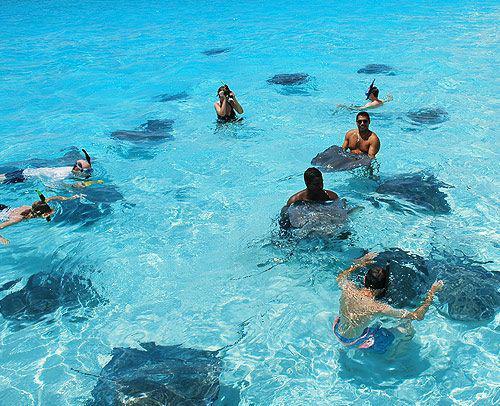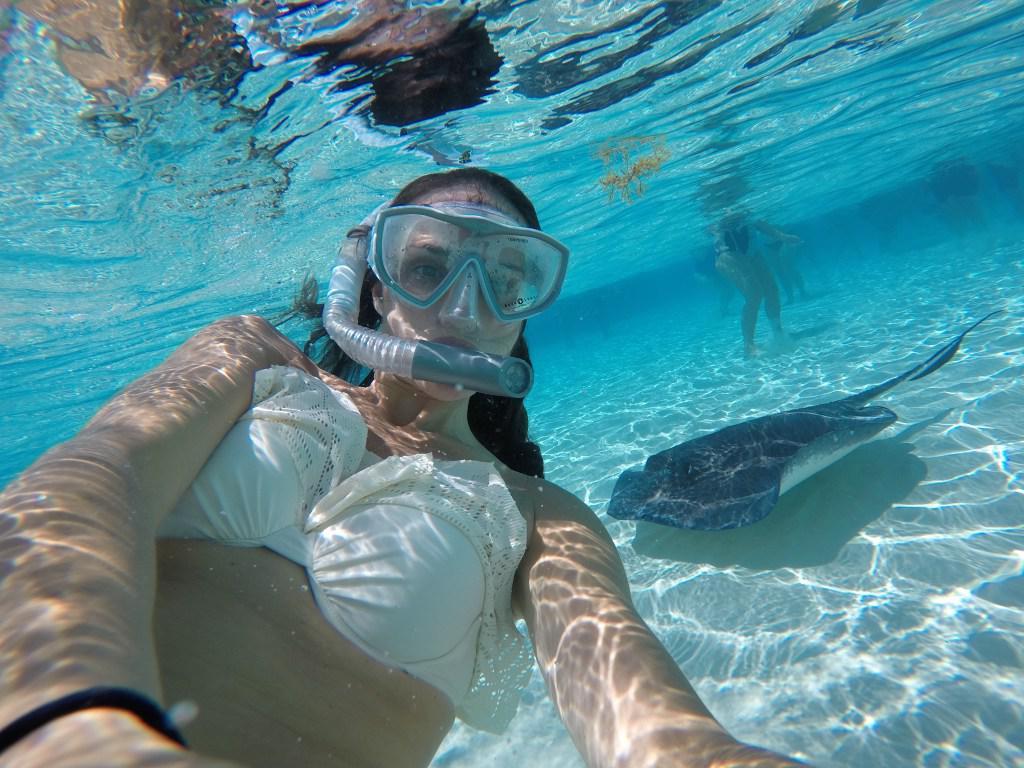The first image is the image on the left, the second image is the image on the right. For the images shown, is this caption "The right image shows no human beings." true? Answer yes or no. No. The first image is the image on the left, the second image is the image on the right. Examine the images to the left and right. Is the description "The image on the left is taken from out of the water, and the image on the right is taken from in the water." accurate? Answer yes or no. Yes. 